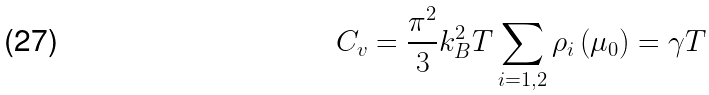Convert formula to latex. <formula><loc_0><loc_0><loc_500><loc_500>C _ { v } = \frac { \pi ^ { 2 } } { 3 } k _ { B } ^ { 2 } T \sum _ { i = 1 , 2 } \rho _ { i } \left ( \mu _ { 0 } \right ) = \gamma T</formula> 